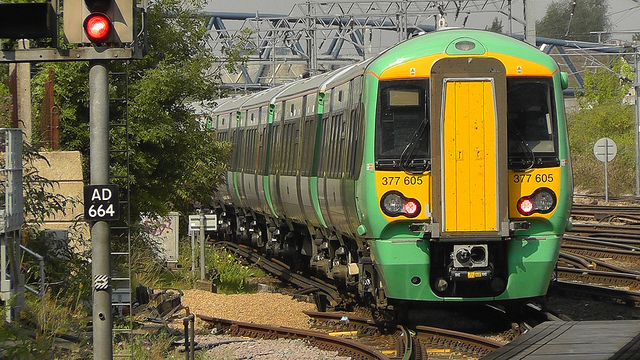Please transcribe the text in this image. 377 605 377 605 664 AD 